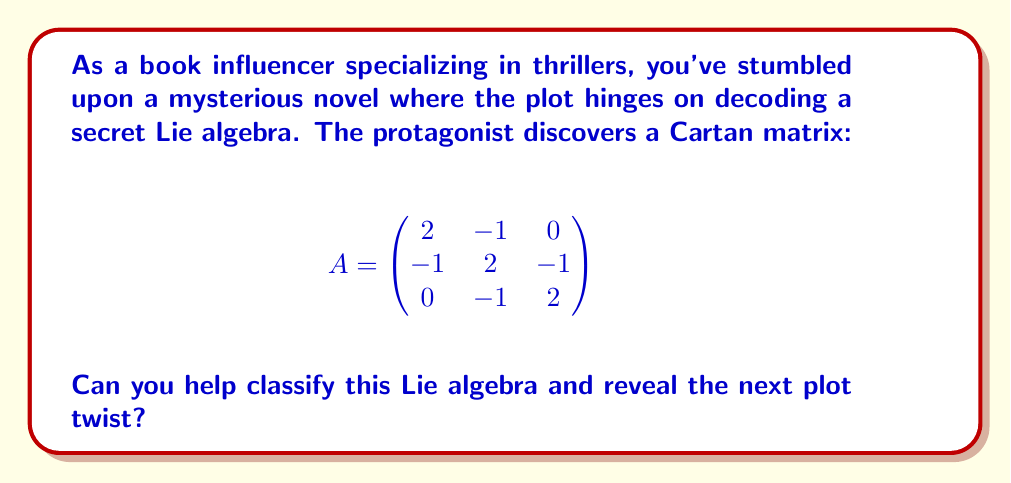What is the answer to this math problem? To classify a Lie algebra based on its Cartan matrix, we need to follow these steps:

1. Identify the type of Cartan matrix:
   This matrix is symmetric and has 2's on the diagonal, which indicates it's a simply-laced Cartan matrix.

2. Count the number of rows/columns:
   The matrix is 3x3, so we're dealing with a rank-3 Lie algebra.

3. Examine the off-diagonal elements:
   The non-zero off-diagonal elements are all -1, confirming it's simply-laced.

4. Construct the Dynkin diagram:
   - Each row/column represents a node.
   - Connect nodes i and j with a single line if $A_{ij} = A_{ji} = -1$.
   - Leave nodes unconnected if $A_{ij} = A_{ji} = 0$.

   The resulting Dynkin diagram is:

   [asy]
   unitsize(1cm);
   dot((0,0)); dot((1,0)); dot((2,0));
   draw((0,0)--(2,0));
   label("1", (0,0), S);
   label("2", (1,0), S);
   label("3", (2,0), S);
   [/asy]

5. Identify the Dynkin diagram:
   This linear diagram with 3 nodes corresponds to the $A_3$ Dynkin diagram.

6. Determine the Lie algebra:
   The $A_3$ Dynkin diagram represents the Lie algebra $\mathfrak{sl}(4, \mathbb{C})$, which is also isomorphic to $\mathfrak{su}(4)$.

Therefore, the Lie algebra represented by this Cartan matrix is classified as $A_3$, corresponding to $\mathfrak{sl}(4, \mathbb{C})$ or $\mathfrak{su}(4)$.
Answer: The Lie algebra is classified as $A_3$, corresponding to $\mathfrak{sl}(4, \mathbb{C})$ or $\mathfrak{su}(4)$. 